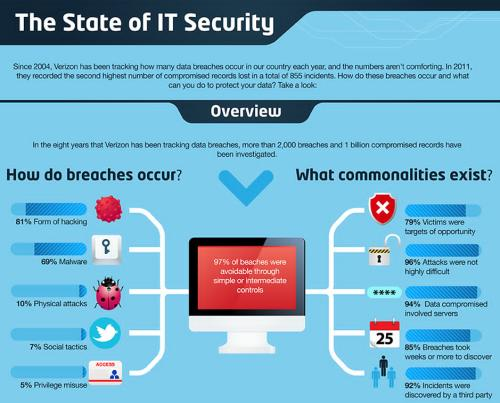Point out several critical features in this image. The report found that 97% of the security breaches could have been avoided. The most common method of security breaches is hacking. Three less commonly used methods in security breaches are physical attacks, social tactics, and privilege misuse. Malware is the second most common way in which security breaches occur. 